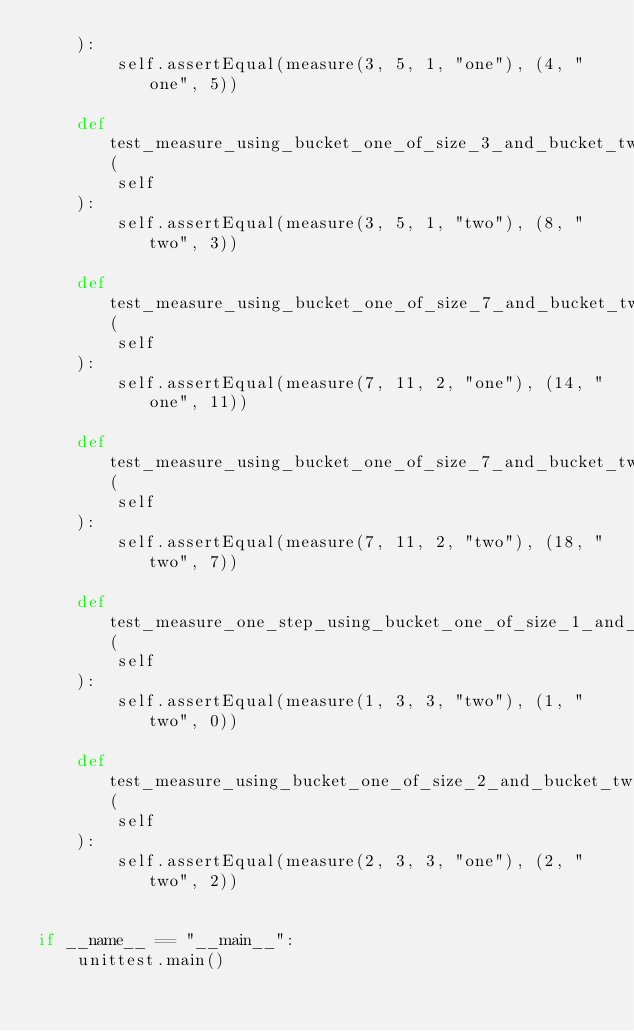<code> <loc_0><loc_0><loc_500><loc_500><_Python_>    ):
        self.assertEqual(measure(3, 5, 1, "one"), (4, "one", 5))

    def test_measure_using_bucket_one_of_size_3_and_bucket_two_of_size_5_start_with_bucket_two(
        self
    ):
        self.assertEqual(measure(3, 5, 1, "two"), (8, "two", 3))

    def test_measure_using_bucket_one_of_size_7_and_bucket_two_of_size_11_start_with_bucket_one(
        self
    ):
        self.assertEqual(measure(7, 11, 2, "one"), (14, "one", 11))

    def test_measure_using_bucket_one_of_size_7_and_bucket_two_of_size_11_start_with_bucket_two(
        self
    ):
        self.assertEqual(measure(7, 11, 2, "two"), (18, "two", 7))

    def test_measure_one_step_using_bucket_one_of_size_1_and_bucket_two_of_size_3_start_with_bucket_two(
        self
    ):
        self.assertEqual(measure(1, 3, 3, "two"), (1, "two", 0))

    def test_measure_using_bucket_one_of_size_2_and_bucket_two_of_size_3_start_with_bucket_one_and_end_with_bucket_two(
        self
    ):
        self.assertEqual(measure(2, 3, 3, "one"), (2, "two", 2))


if __name__ == "__main__":
    unittest.main()
</code> 